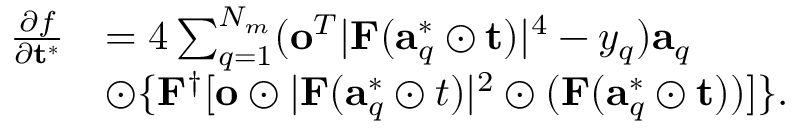Convert formula to latex. <formula><loc_0><loc_0><loc_500><loc_500>\begin{array} { r l } { \frac { \partial f } { \partial t ^ { * } } } & { = 4 \sum _ { q = 1 } ^ { N _ { m } } ( o ^ { T } | F ( a _ { q } ^ { * } \odot t ) | ^ { 4 } - y _ { q } ) a _ { q } } \\ & { \odot \{ F ^ { \dag } [ o \odot | F ( a _ { q } ^ { * } \odot t ) | ^ { 2 } \odot ( F ( a _ { q } ^ { * } \odot t ) ) ] \} . } \end{array}</formula> 